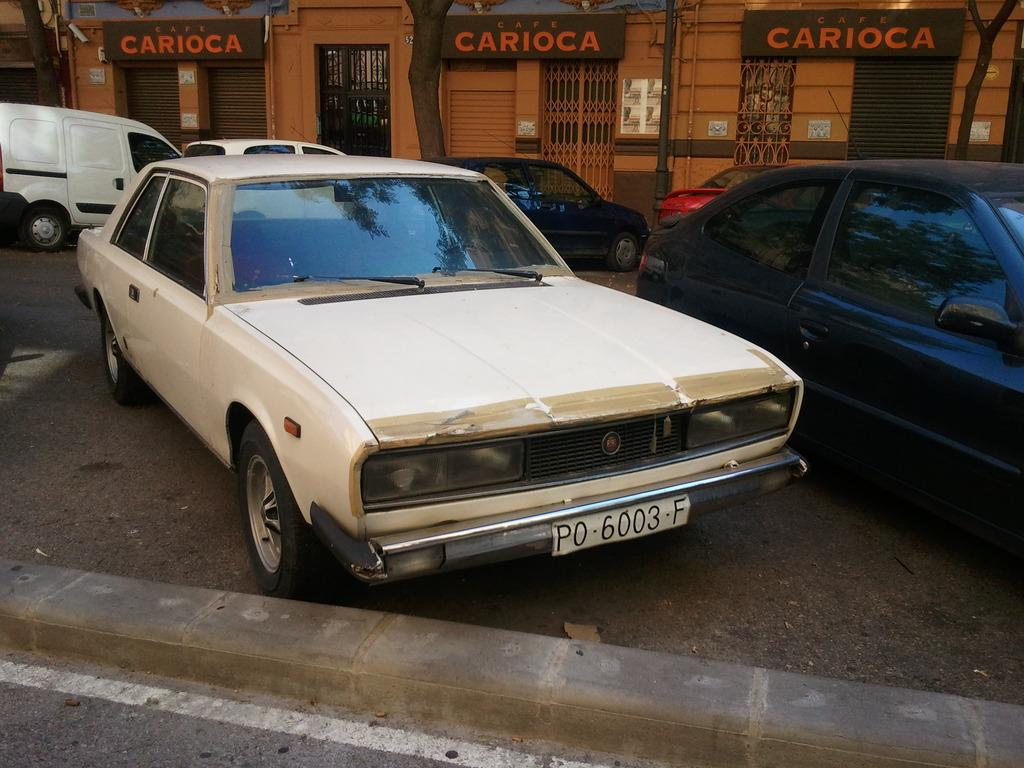What can be seen on the road in the image? There are vehicles on the road in the image. What is visible in the background of the image? In the background of the image, there is a pole, posters, shutters, grilles, and tree trunks. What type of songs can be heard coming from the grape in the image? There is no grape present in the image, and therefore no songs can be heard from it. What observation can be made about the tree trunks in the image? The provided facts do not mention any specific observations about the tree trunks, so we cannot answer this question based on the given information. 